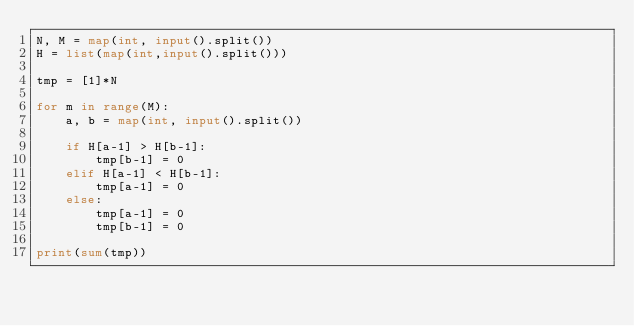<code> <loc_0><loc_0><loc_500><loc_500><_Python_>N, M = map(int, input().split())
H = list(map(int,input().split()))

tmp = [1]*N

for m in range(M):
    a, b = map(int, input().split())

    if H[a-1] > H[b-1]:
        tmp[b-1] = 0
    elif H[a-1] < H[b-1]:
        tmp[a-1] = 0
    else:
        tmp[a-1] = 0
        tmp[b-1] = 0

print(sum(tmp))
</code> 